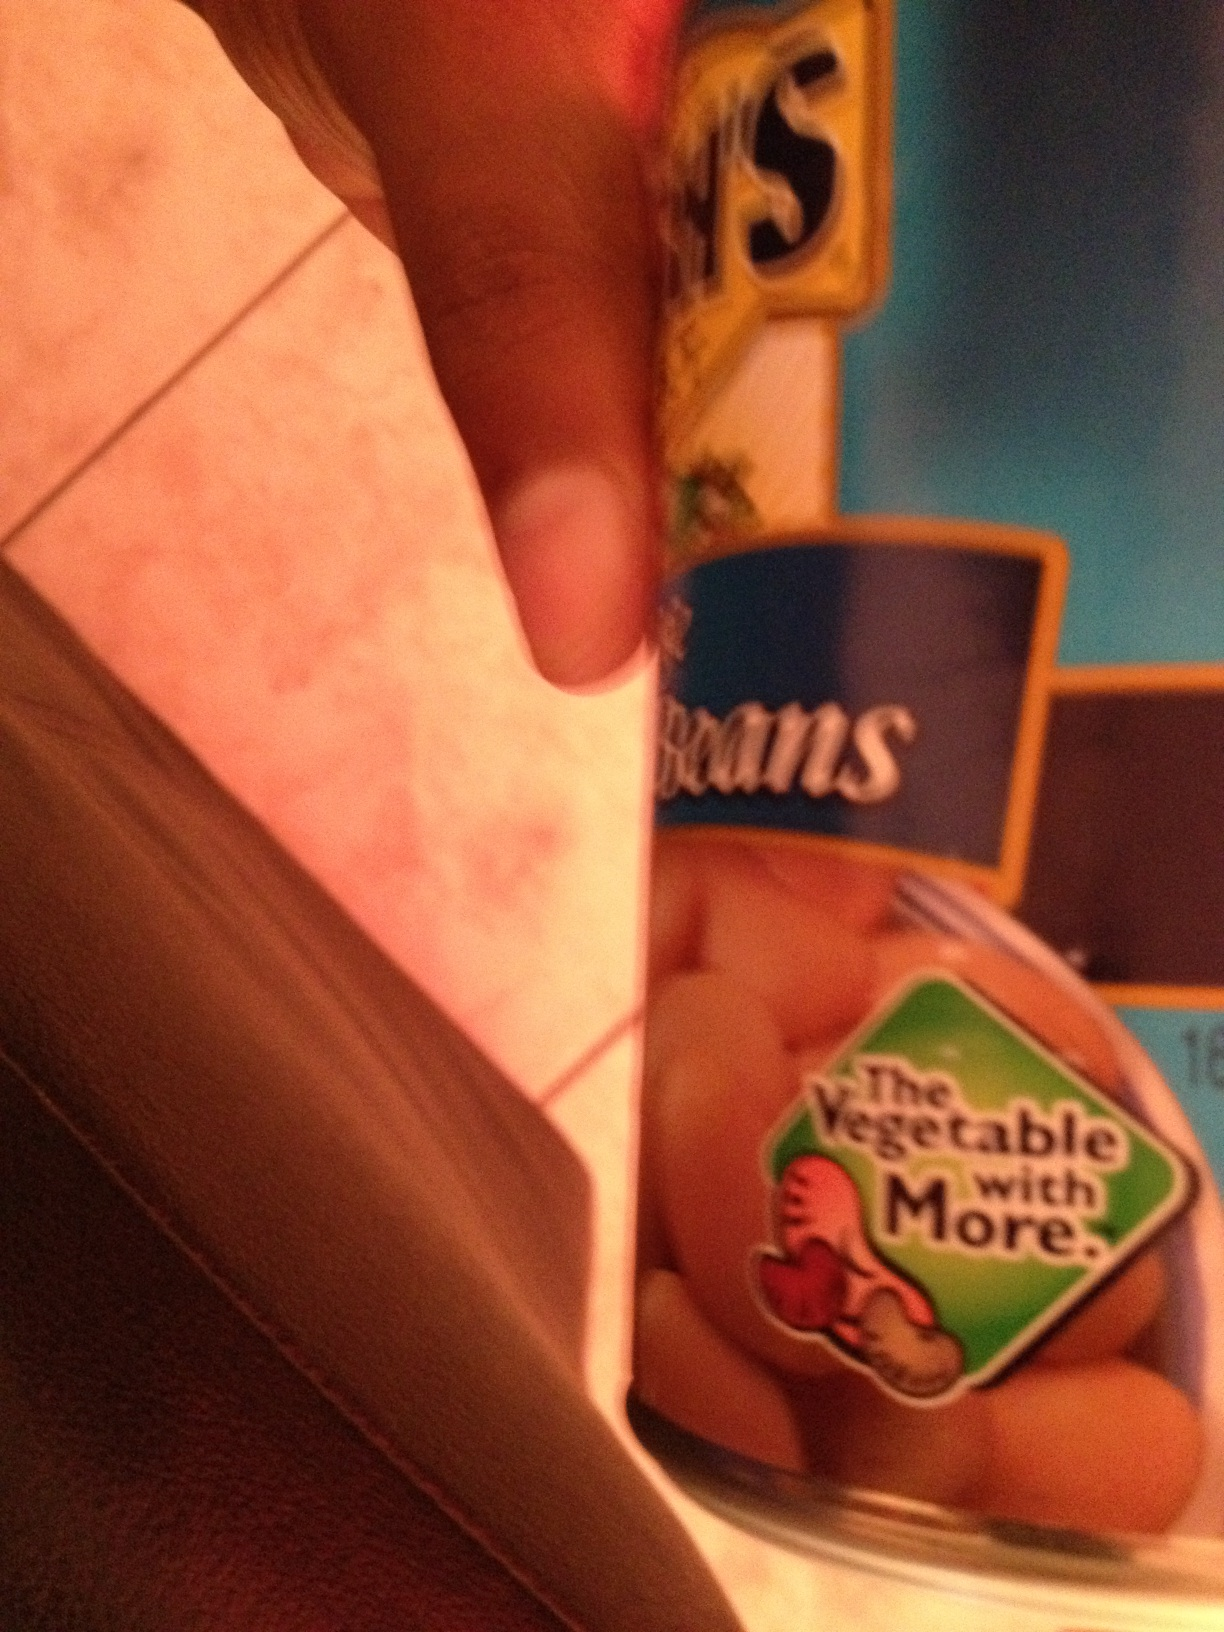hello can you please tell me what a can of beans is thank you from Vizwiz Certainly! The image shows a can of 'Bush's Best Pinto Beans.' Pinto beans are a variety of beans with a creamy texture and a slightly nutty flavor. They're widely used in Mexican and Tex-Mex cuisine, often in dishes like burritos and chili. This specific brand, Bush's Best, is known for its variety of canned beans that are ready to eat or add to recipes. They are a good source of protein and fiber. 